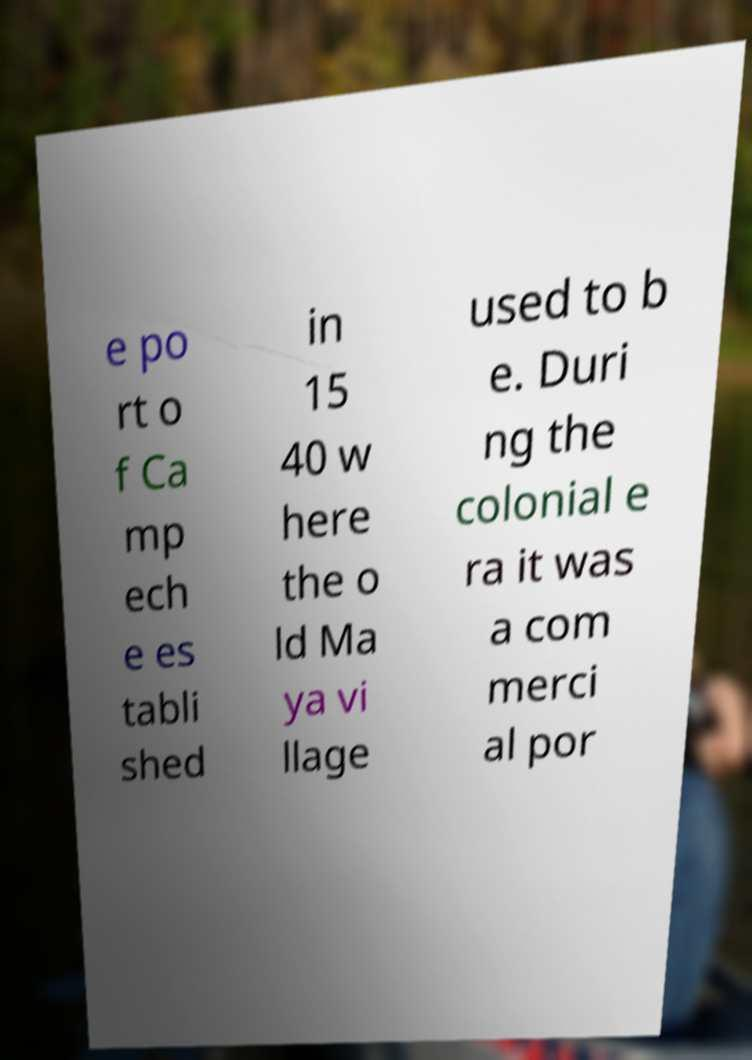For documentation purposes, I need the text within this image transcribed. Could you provide that? e po rt o f Ca mp ech e es tabli shed in 15 40 w here the o ld Ma ya vi llage used to b e. Duri ng the colonial e ra it was a com merci al por 